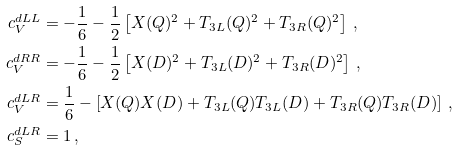Convert formula to latex. <formula><loc_0><loc_0><loc_500><loc_500>c _ { V } ^ { d L L } & = - \frac { 1 } { 6 } - \frac { 1 } { 2 } \left [ X ( Q ) ^ { 2 } + T _ { 3 L } ( Q ) ^ { 2 } + T _ { 3 R } ( Q ) ^ { 2 } \right ] \, , \\ c _ { V } ^ { d R R } & = - \frac { 1 } { 6 } - \frac { 1 } { 2 } \left [ X ( D ) ^ { 2 } + T _ { 3 L } ( D ) ^ { 2 } + T _ { 3 R } ( D ) ^ { 2 } \right ] \, , \\ c _ { V } ^ { d L R } & = \frac { 1 } { 6 } - \left [ X ( Q ) X ( D ) + T _ { 3 L } ( Q ) T _ { 3 L } ( D ) + T _ { 3 R } ( Q ) T _ { 3 R } ( D ) \right ] \, , \\ c _ { S } ^ { d L R } & = 1 \, ,</formula> 